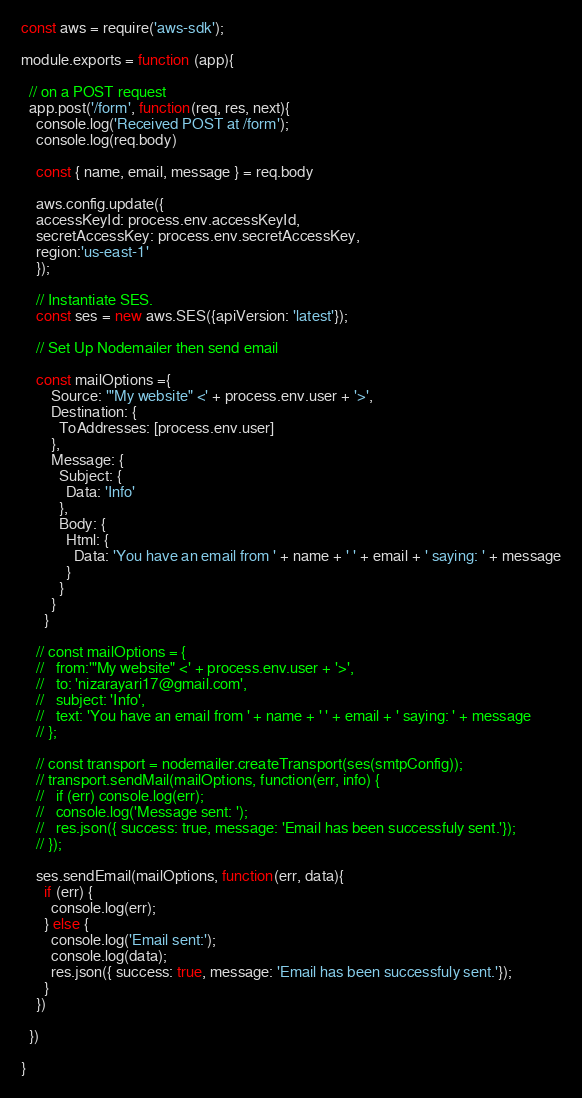<code> <loc_0><loc_0><loc_500><loc_500><_JavaScript_>const aws = require('aws-sdk');

module.exports = function (app){
  
  // on a POST request
  app.post('/form', function(req, res, next){
    console.log('Received POST at /form');
    console.log(req.body)

    const { name, email, message } = req.body

    aws.config.update({
    accessKeyId: process.env.accessKeyId,
    secretAccessKey: process.env.secretAccessKey,
    region:'us-east-1'
    }); 

    // Instantiate SES.
    const ses = new aws.SES({apiVersion: 'latest'});

    // Set Up Nodemailer then send email
    
    const mailOptions ={
        Source: '"My website" <' + process.env.user + '>',
        Destination: {
          ToAddresses: [process.env.user]
        },
        Message: {
          Subject: {
            Data: 'Info'
          },
          Body: {
            Html: {
              Data: 'You have an email from ' + name + ' ' + email + ' saying: ' + message
            }
          }
        }
      }

    // const mailOptions = {
    //   from:'"My website" <' + process.env.user + '>',
    //   to: 'nizarayari17@gmail.com',
    //   subject: 'Info',
    //   text: 'You have an email from ' + name + ' ' + email + ' saying: ' + message 
    // };

    // const transport = nodemailer.createTransport(ses(smtpConfig));
    // transport.sendMail(mailOptions, function(err, info) {
    //   if (err) console.log(err);
    //   console.log('Message sent: ');
    //   res.json({ success: true, message: 'Email has been successfuly sent.'});
    // });

    ses.sendEmail(mailOptions, function(err, data){
      if (err) {
        console.log(err);
      } else {
        console.log('Email sent:');
        console.log(data);
        res.json({ success: true, message: 'Email has been successfuly sent.'});
      }
    })

  })

}</code> 